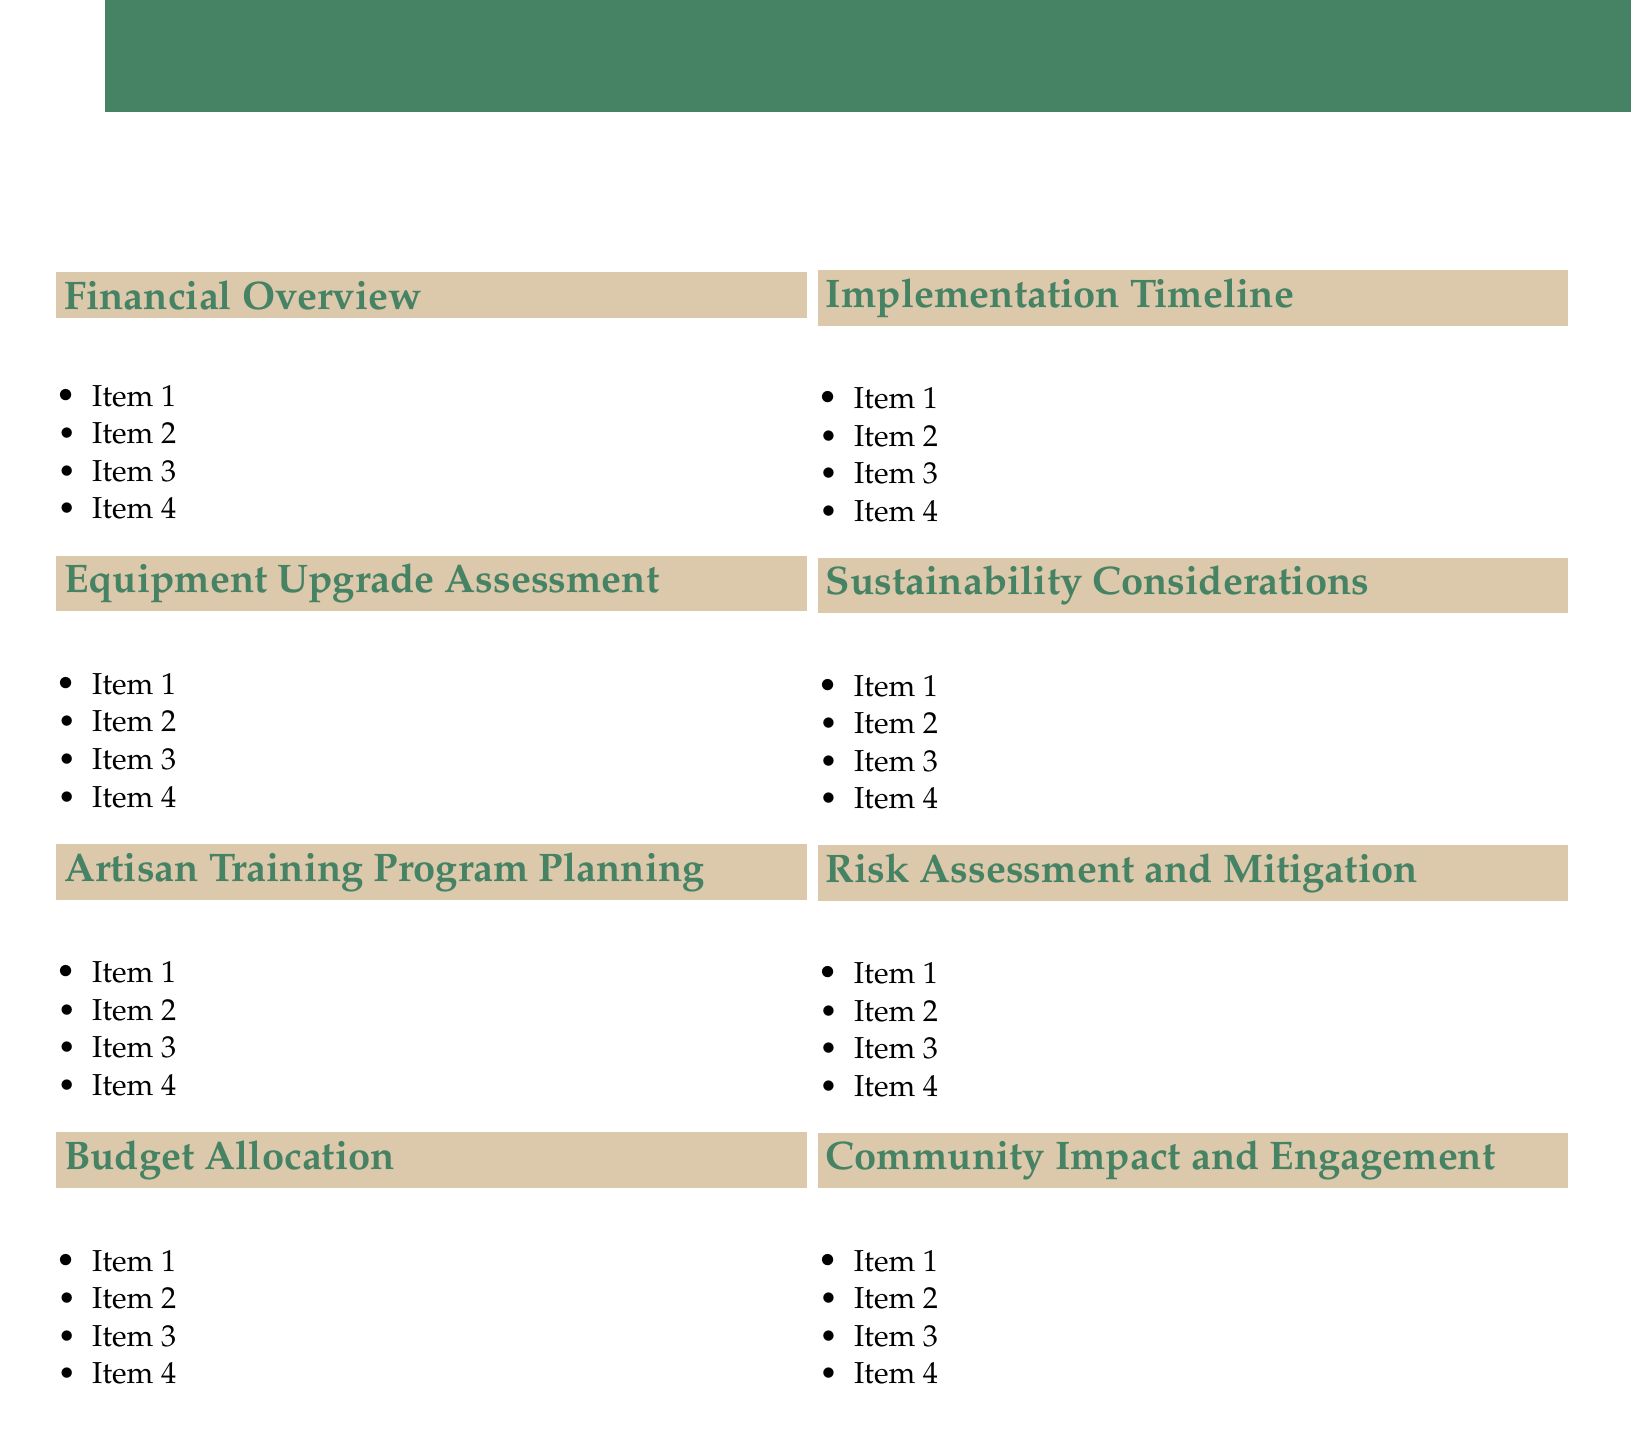What is the agenda title? The agenda title outlines the main focus of this document, which details the purpose of the meeting.
Answer: Annual Budget Planning for Equipment Upgrades and Artisan Training Programs What organization is mentioned for potential grants? This organization could provide funding opportunities for the textile producer's initiatives.
Answer: Vermont Arts Council How many sections are there in the agenda? Sections in the document are each categorized separates topics related to the budgeting process.
Answer: Eight What technology is being evaluated for cost analysis? This technology represents an eco-friendly upgrade potential for textile production equipment.
Answer: Solar-powered dyeing vats Who is a proposed collaborator for training programs? This person is an expert whose knowledge could enhance the effectiveness of the training initiatives.
Answer: Sarah Haskell What type of expenses should reserve funds cover? These funds are essential for ensuring flexibility in the budgeting process, allowing for preparedness for the unexpected.
Answer: Unexpected expenses or opportunities What are the proposed new training modules focused on? This information highlights the areas where artisans need additional skills to improve their craft and sustainability.
Answer: Natural dyeing techniques and sustainable weaving practices What is a planned local event for showcasing improvements? This event provides a platform for artisans to present their enhanced skills and products to a wider audience.
Answer: Vermont Sheep & Wool Festival 